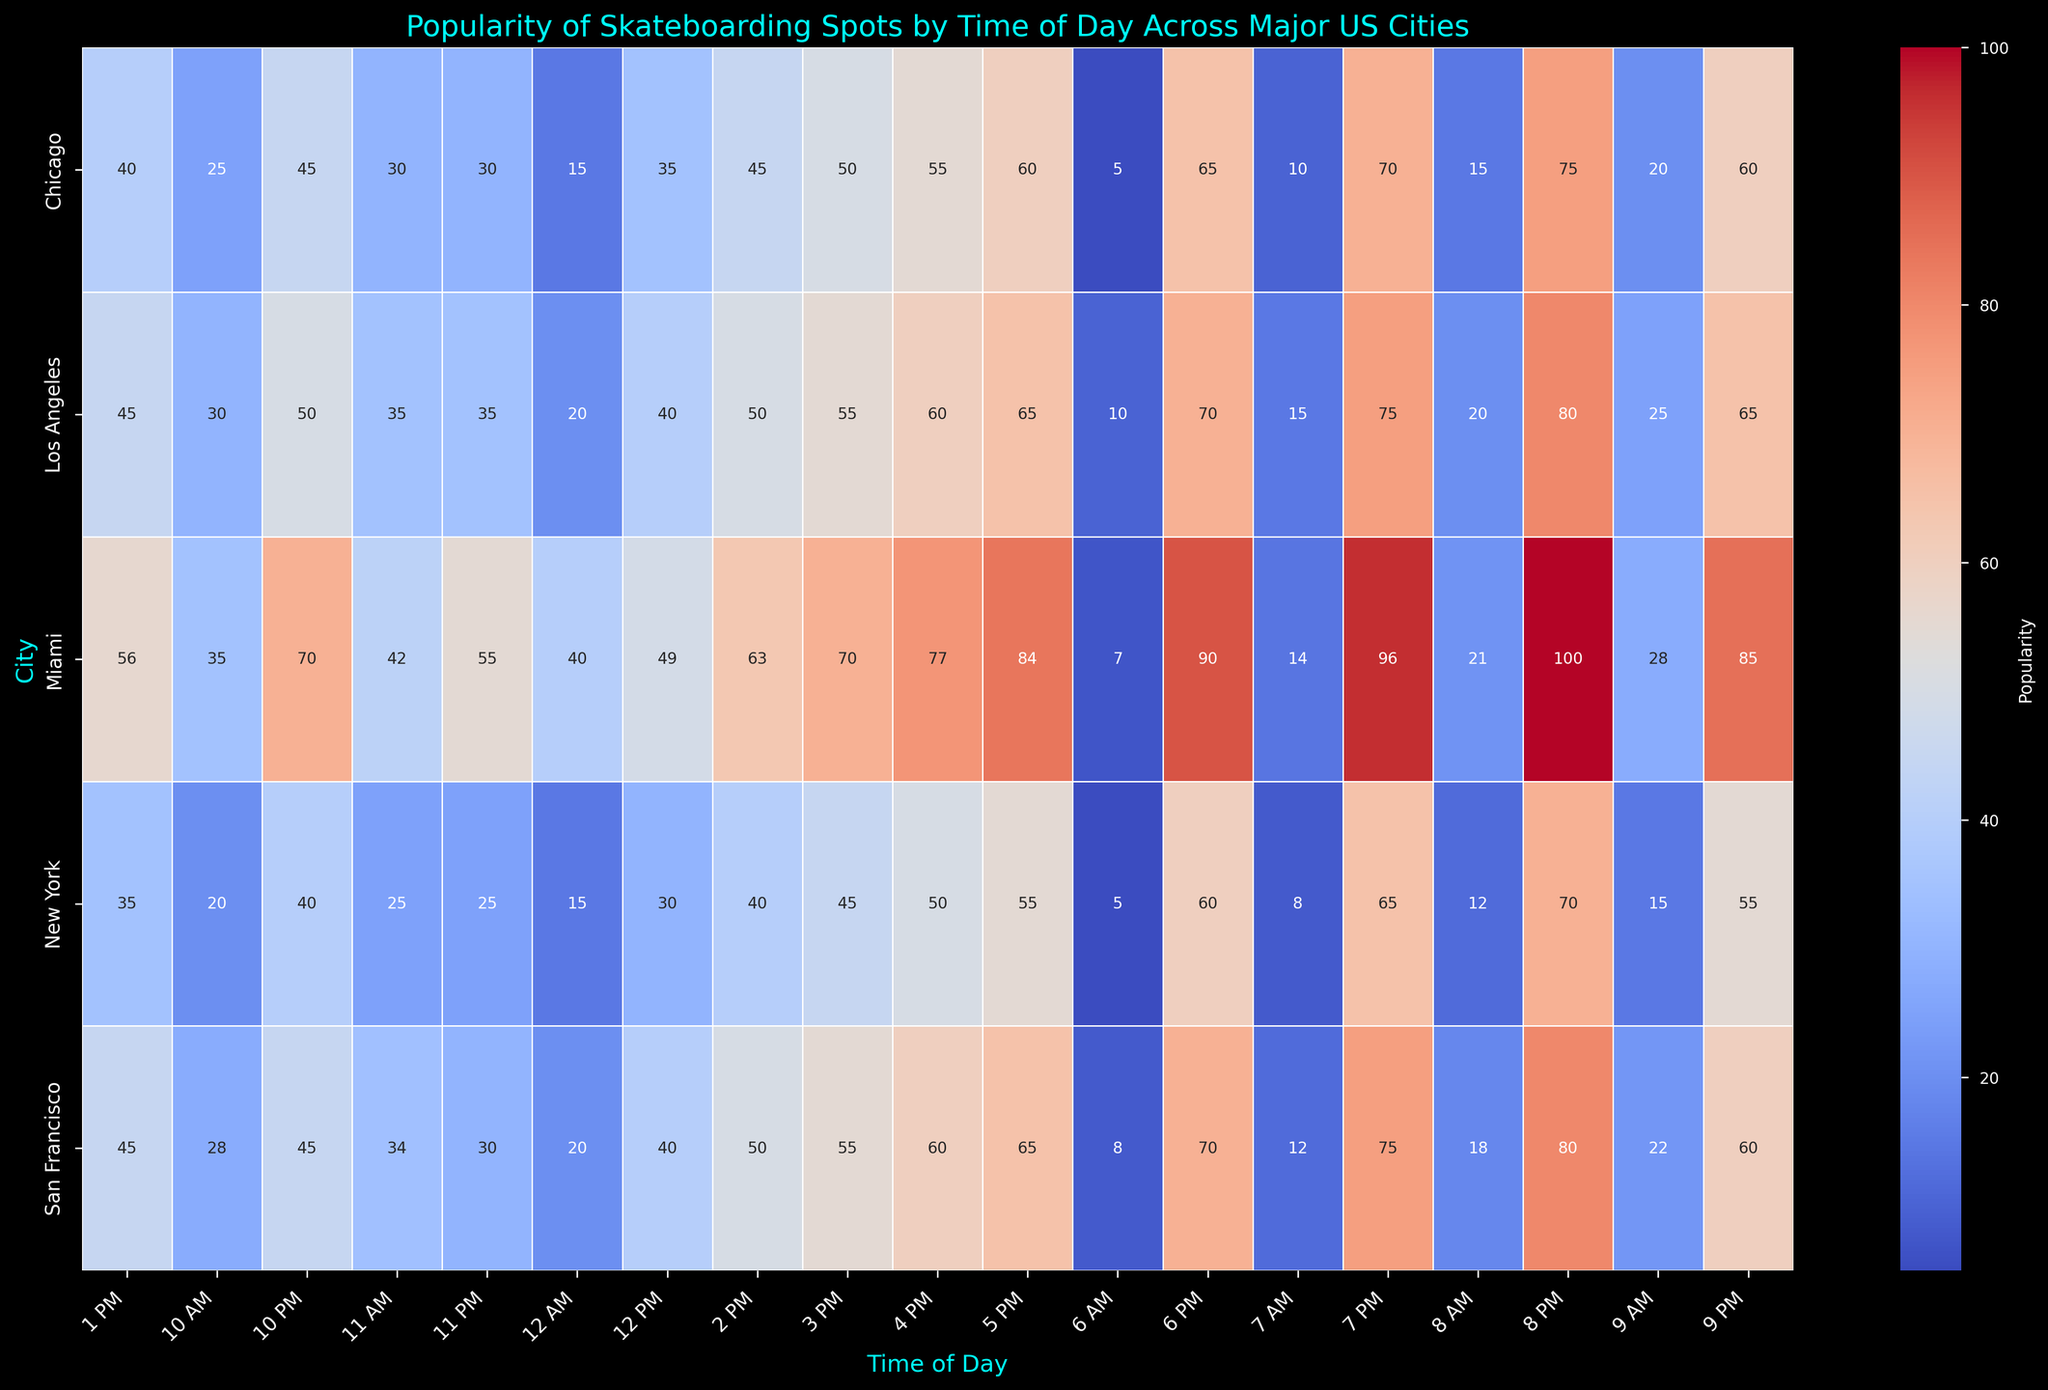What is the city with the highest popularity at 8 PM? By looking at the heatmap, we find the cell corresponding to 8 PM in each row (city). The city with the darkest (most intense) color at that time is the one with the highest popularity.
Answer: Miami What is the least popular time for skateboarding in Los Angeles? We check the row for Los Angeles on the heatmap and identify the cell with the least intense color, corresponding to the lowest numerical value.
Answer: 6 AM How does the popularity at 3 PM compare between Chicago and San Francisco? Compare the color intensity or numerical values in the cells for 3 PM in the rows for Chicago and San Francisco. Chicago shows a value of 50, whereas San Francisco shows a value of 55.
Answer: San Francisco is more popular at 3 PM than Chicago What is the average popularity from 6 AM to 12 PM in New York? Sum the popularity values from 6 AM to 12 PM for New York (5 + 8 + 12 + 15 + 20 + 25) and then divide by the number of time slots (6).
Answer: 14.17 At what time does Miami reach its peak popularity? In the row for Miami, identify the cell with the highest intensity color, corresponding to the highest numerical value.
Answer: 8 PM Which city experiences the most significant drop in popularity from 9 PM to 10 PM? Subtract the value at 10 PM from the value at 9 PM for each city and compare the differences. Miami has the largest drop (85 - 70 = 15).
Answer: Miami What's the sum of the popularity scores in Chicago from 6 PM to 9 PM? Sum the popularity values from 6 PM to 9 PM for Chicago (65 + 70 + 75 + 60).
Answer: 270 How does the color intensity change from 6 PM to 9 PM in Los Angeles? Observe the color changes in the row for Los Angeles from 6 PM to 9 PM. The color starts intense (darkest) at 6 PM and gradually becomes lighter by 9 PM.
Answer: Decreases In which city is the 7 PM slot most and least popular? Check the popularity values at 7 PM across all cities. Miami has the highest value (96), and New York has the lowest (65).
Answer: Most popular in Miami, least popular in New York What is the total number of popularities recorded across all cities at noon (12 PM)? Sum the popularity values at 12 PM for all cities (30 + 40 + 35 + 40 + 49).
Answer: 194 